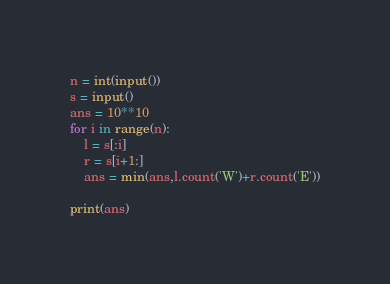<code> <loc_0><loc_0><loc_500><loc_500><_Python_>n = int(input())
s = input()
ans = 10**10
for i in range(n):
    l = s[:i]
    r = s[i+1:]
    ans = min(ans,l.count('W')+r.count('E'))

print(ans)</code> 